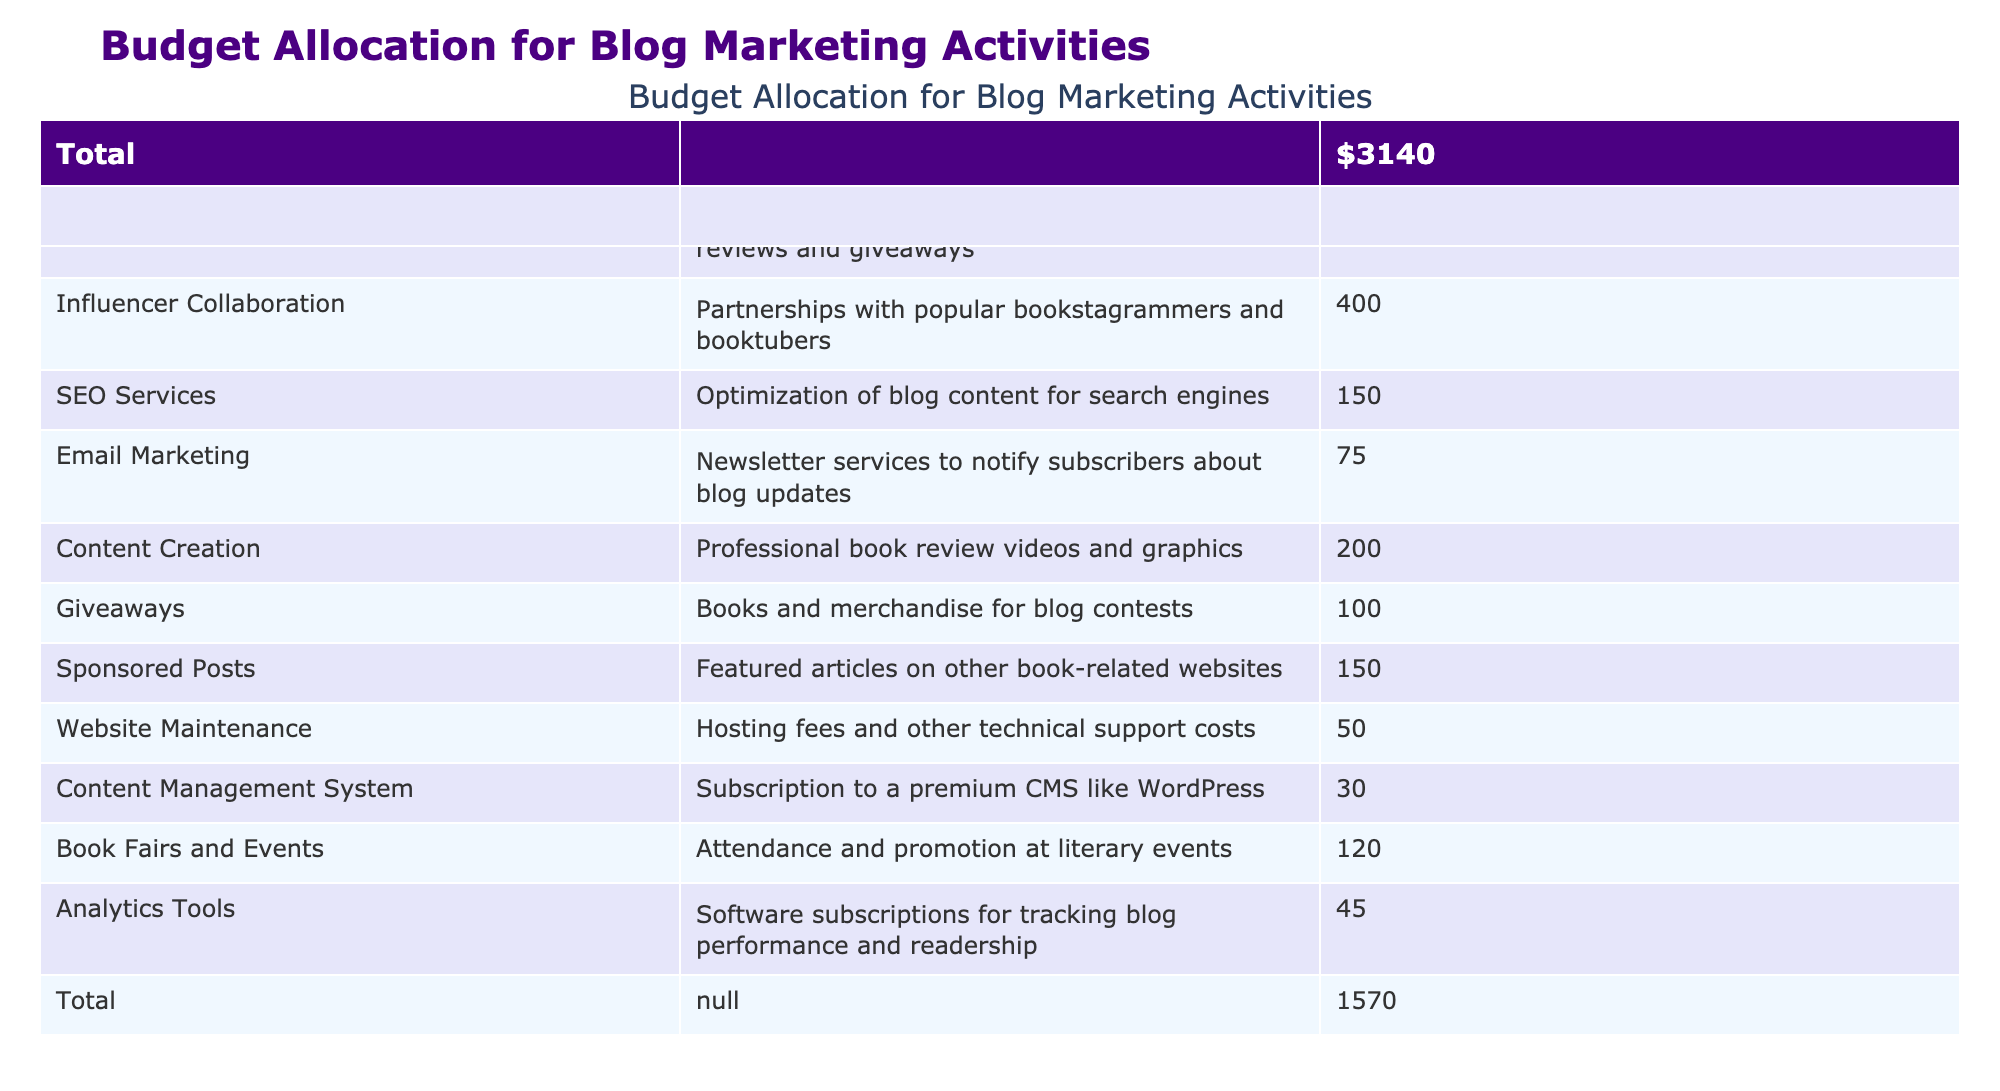What is the budget allocated for influencer collaboration? In the table, the category "Influencer Collaboration" has a specified monthly budget listed directly under the "Monthly Budget (USD)" column, which shows the amount as 400.
Answer: 400 How much is spent on social media advertising and giveaways combined? The budget for "Social Media Advertising" is 250, and the budget for "Giveaways" is 100. Adding these together gives 250 + 100 = 350.
Answer: 350 Is the monthly budget for SEO services greater than that for email marketing? The "SEO Services" budget is 150, while the "Email Marketing" budget is 75. Since 150 is greater than 75, the statement is true.
Answer: Yes What category has the lowest monthly budget, and what is that amount? Scanning the table, "Content Management System" has the lowest amount listed at 30.
Answer: Content Management System, 30 What is the total budget allocated for all marketing activities? The total budget can be found in the last row of the table, where it summarizes all the monthly budgets. It shows a total of 1570.
Answer: 1570 How much more is spent on influencer collaboration compared to email marketing? The "Influencer Collaboration" budget is 400, and the "Email Marketing" budget is 75. Subtracting these gives 400 - 75 = 325.
Answer: 325 If we combine the budgets for content creation and sponsored posts, what will the total be? "Content Creation" has a budget of 200, and "Sponsored Posts" has a budget of 150. Adding these together results in 200 + 150 = 350.
Answer: 350 Which category contributes more to the monthly budget, social media advertising or website maintenance, and by how much? The "Social Media Advertising" budget is 250 and "Website Maintenance" is 50. The difference is 250 - 50 = 200. So, social media advertising contributes more by 200.
Answer: 200 How does the combined cost of analytics tools and email marketing compare to the cost of giveaways? "Analytics Tools" costs 45 and "Email Marketing" costs 75, so their combined cost is 45 + 75 = 120. The cost of "Giveaways" is 100. Since 120 is greater than 100, they are more expensive together.
Answer: Yes 